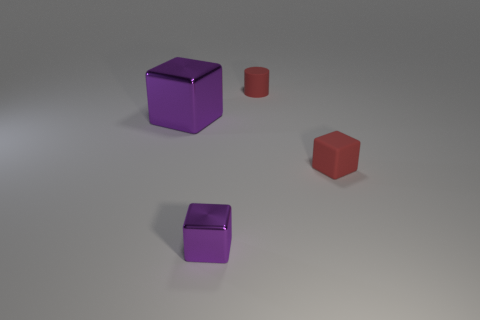Add 1 large purple metallic objects. How many objects exist? 5 Subtract all cubes. How many objects are left? 1 Subtract all small purple metal blocks. Subtract all tiny blue rubber cylinders. How many objects are left? 3 Add 3 red matte objects. How many red matte objects are left? 5 Add 2 purple shiny cubes. How many purple shiny cubes exist? 4 Subtract 0 brown balls. How many objects are left? 4 